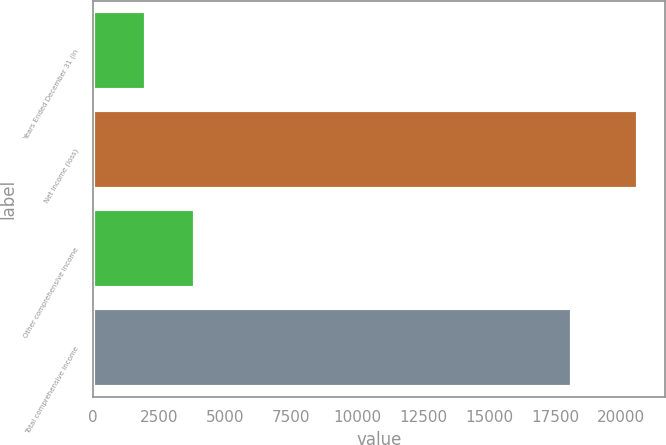Convert chart. <chart><loc_0><loc_0><loc_500><loc_500><bar_chart><fcel>Years Ended December 31 (in<fcel>Net income (loss)<fcel>Other comprehensive income<fcel>Total comprehensive income<nl><fcel>2011<fcel>20622<fcel>3872.1<fcel>18139<nl></chart> 